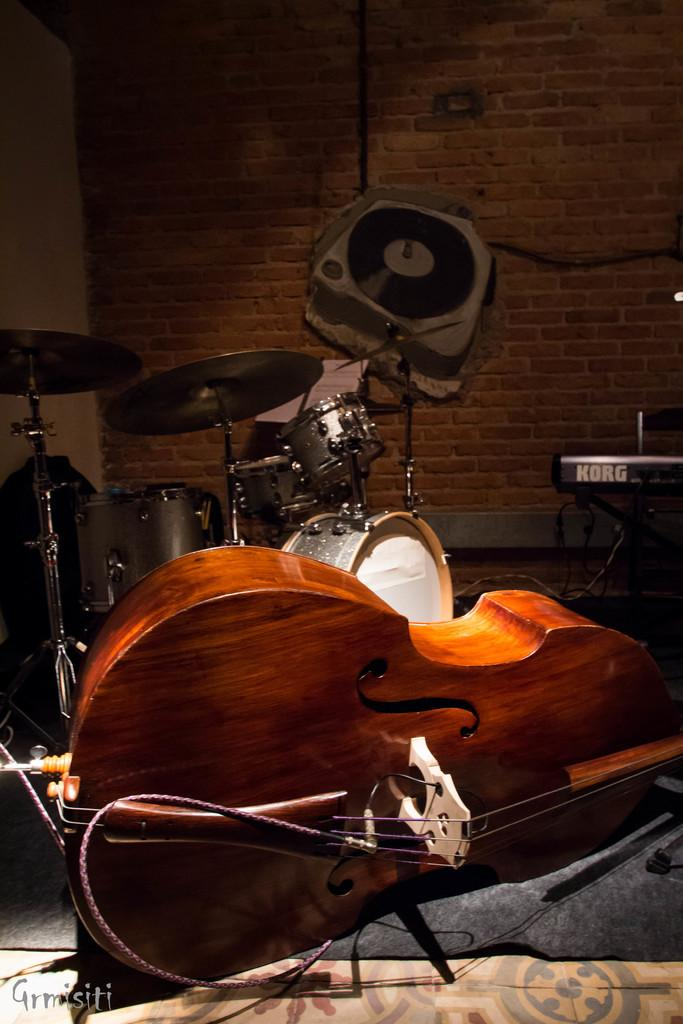What musical instruments are present in the image? There is a guitar, drums, and a keyboard in the image. What type of structure can be seen in the background of the image? There is a wall in the image. How many children are playing with the twist in the image? There are no children or twist present in the image. 